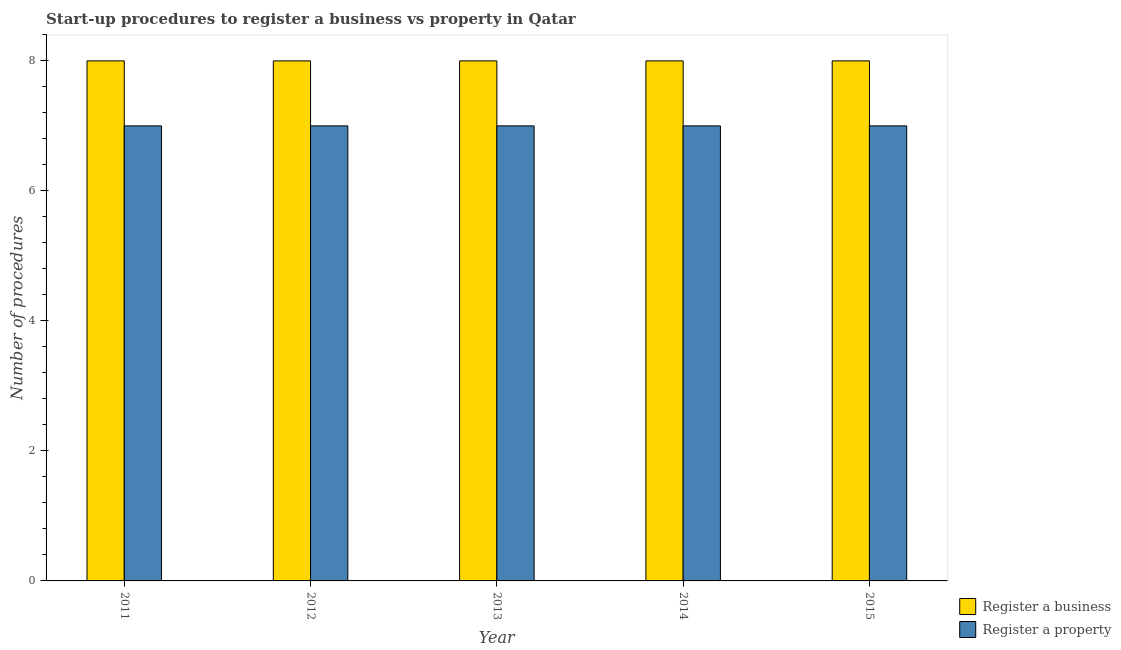How many different coloured bars are there?
Ensure brevity in your answer.  2. How many groups of bars are there?
Offer a very short reply. 5. How many bars are there on the 1st tick from the right?
Keep it short and to the point. 2. What is the label of the 1st group of bars from the left?
Give a very brief answer. 2011. In how many cases, is the number of bars for a given year not equal to the number of legend labels?
Provide a succinct answer. 0. What is the number of procedures to register a property in 2015?
Make the answer very short. 7. Across all years, what is the maximum number of procedures to register a property?
Provide a short and direct response. 7. Across all years, what is the minimum number of procedures to register a property?
Make the answer very short. 7. In which year was the number of procedures to register a property maximum?
Your answer should be very brief. 2011. In which year was the number of procedures to register a property minimum?
Your answer should be very brief. 2011. What is the total number of procedures to register a business in the graph?
Your answer should be compact. 40. What is the difference between the number of procedures to register a business in 2012 and that in 2014?
Ensure brevity in your answer.  0. What is the difference between the number of procedures to register a business in 2013 and the number of procedures to register a property in 2015?
Give a very brief answer. 0. What is the average number of procedures to register a business per year?
Ensure brevity in your answer.  8. In the year 2011, what is the difference between the number of procedures to register a business and number of procedures to register a property?
Keep it short and to the point. 0. In how many years, is the number of procedures to register a business greater than 2?
Provide a short and direct response. 5. Is the number of procedures to register a property in 2013 less than that in 2014?
Provide a short and direct response. No. Is the difference between the number of procedures to register a property in 2012 and 2013 greater than the difference between the number of procedures to register a business in 2012 and 2013?
Offer a very short reply. No. What is the difference between the highest and the lowest number of procedures to register a business?
Make the answer very short. 0. In how many years, is the number of procedures to register a business greater than the average number of procedures to register a business taken over all years?
Ensure brevity in your answer.  0. Is the sum of the number of procedures to register a business in 2013 and 2015 greater than the maximum number of procedures to register a property across all years?
Your response must be concise. Yes. What does the 1st bar from the left in 2015 represents?
Your answer should be compact. Register a business. What does the 1st bar from the right in 2014 represents?
Ensure brevity in your answer.  Register a property. How many bars are there?
Offer a terse response. 10. How many years are there in the graph?
Give a very brief answer. 5. Are the values on the major ticks of Y-axis written in scientific E-notation?
Offer a terse response. No. Does the graph contain any zero values?
Make the answer very short. No. Where does the legend appear in the graph?
Provide a short and direct response. Bottom right. How many legend labels are there?
Ensure brevity in your answer.  2. What is the title of the graph?
Offer a terse response. Start-up procedures to register a business vs property in Qatar. What is the label or title of the X-axis?
Provide a succinct answer. Year. What is the label or title of the Y-axis?
Keep it short and to the point. Number of procedures. What is the Number of procedures of Register a property in 2011?
Ensure brevity in your answer.  7. What is the Number of procedures of Register a business in 2013?
Your answer should be compact. 8. What is the Number of procedures in Register a property in 2013?
Your answer should be very brief. 7. What is the Number of procedures in Register a property in 2014?
Your answer should be compact. 7. What is the Number of procedures of Register a business in 2015?
Give a very brief answer. 8. What is the Number of procedures in Register a property in 2015?
Ensure brevity in your answer.  7. Across all years, what is the maximum Number of procedures of Register a business?
Offer a very short reply. 8. Across all years, what is the maximum Number of procedures of Register a property?
Your response must be concise. 7. Across all years, what is the minimum Number of procedures in Register a business?
Give a very brief answer. 8. What is the total Number of procedures in Register a property in the graph?
Make the answer very short. 35. What is the difference between the Number of procedures in Register a business in 2011 and that in 2012?
Ensure brevity in your answer.  0. What is the difference between the Number of procedures in Register a property in 2011 and that in 2012?
Offer a terse response. 0. What is the difference between the Number of procedures in Register a business in 2011 and that in 2013?
Offer a very short reply. 0. What is the difference between the Number of procedures in Register a business in 2011 and that in 2014?
Your answer should be compact. 0. What is the difference between the Number of procedures of Register a property in 2011 and that in 2014?
Your answer should be very brief. 0. What is the difference between the Number of procedures of Register a business in 2012 and that in 2014?
Your answer should be compact. 0. What is the difference between the Number of procedures of Register a business in 2012 and that in 2015?
Ensure brevity in your answer.  0. What is the difference between the Number of procedures of Register a property in 2012 and that in 2015?
Your answer should be very brief. 0. What is the difference between the Number of procedures in Register a property in 2013 and that in 2014?
Offer a very short reply. 0. What is the difference between the Number of procedures in Register a business in 2013 and that in 2015?
Ensure brevity in your answer.  0. What is the difference between the Number of procedures of Register a business in 2011 and the Number of procedures of Register a property in 2012?
Offer a very short reply. 1. What is the difference between the Number of procedures in Register a business in 2011 and the Number of procedures in Register a property in 2013?
Keep it short and to the point. 1. What is the difference between the Number of procedures of Register a business in 2011 and the Number of procedures of Register a property in 2014?
Your answer should be compact. 1. What is the difference between the Number of procedures in Register a business in 2012 and the Number of procedures in Register a property in 2015?
Ensure brevity in your answer.  1. What is the difference between the Number of procedures in Register a business in 2013 and the Number of procedures in Register a property in 2014?
Give a very brief answer. 1. What is the difference between the Number of procedures of Register a business in 2013 and the Number of procedures of Register a property in 2015?
Keep it short and to the point. 1. What is the difference between the Number of procedures of Register a business in 2014 and the Number of procedures of Register a property in 2015?
Keep it short and to the point. 1. What is the average Number of procedures in Register a property per year?
Offer a terse response. 7. In the year 2011, what is the difference between the Number of procedures in Register a business and Number of procedures in Register a property?
Your response must be concise. 1. In the year 2013, what is the difference between the Number of procedures of Register a business and Number of procedures of Register a property?
Offer a terse response. 1. In the year 2014, what is the difference between the Number of procedures of Register a business and Number of procedures of Register a property?
Ensure brevity in your answer.  1. What is the ratio of the Number of procedures of Register a business in 2011 to that in 2012?
Keep it short and to the point. 1. What is the ratio of the Number of procedures of Register a business in 2011 to that in 2014?
Keep it short and to the point. 1. What is the ratio of the Number of procedures of Register a business in 2011 to that in 2015?
Provide a short and direct response. 1. What is the ratio of the Number of procedures in Register a property in 2011 to that in 2015?
Make the answer very short. 1. What is the ratio of the Number of procedures in Register a business in 2012 to that in 2013?
Provide a succinct answer. 1. What is the ratio of the Number of procedures of Register a property in 2012 to that in 2013?
Your response must be concise. 1. What is the ratio of the Number of procedures in Register a business in 2012 to that in 2015?
Your answer should be compact. 1. What is the ratio of the Number of procedures in Register a property in 2012 to that in 2015?
Offer a terse response. 1. What is the ratio of the Number of procedures in Register a property in 2013 to that in 2015?
Your answer should be very brief. 1. What is the ratio of the Number of procedures in Register a property in 2014 to that in 2015?
Make the answer very short. 1. What is the difference between the highest and the second highest Number of procedures of Register a business?
Provide a short and direct response. 0. What is the difference between the highest and the lowest Number of procedures in Register a property?
Your answer should be very brief. 0. 